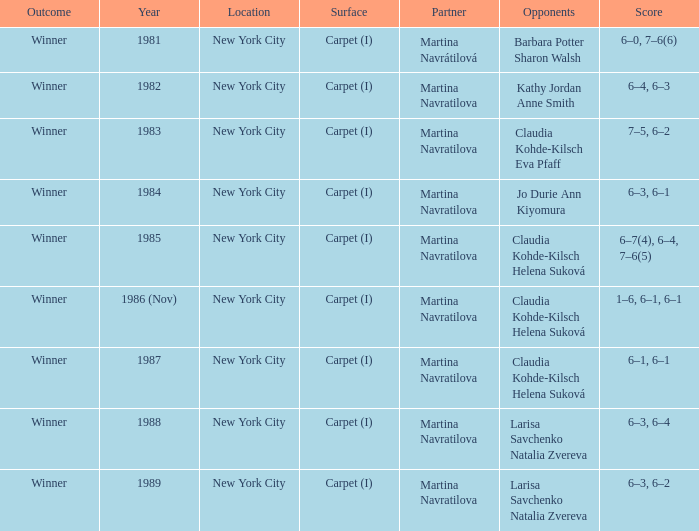Could you help me parse every detail presented in this table? {'header': ['Outcome', 'Year', 'Location', 'Surface', 'Partner', 'Opponents', 'Score'], 'rows': [['Winner', '1981', 'New York City', 'Carpet (I)', 'Martina Navrátilová', 'Barbara Potter Sharon Walsh', '6–0, 7–6(6)'], ['Winner', '1982', 'New York City', 'Carpet (I)', 'Martina Navratilova', 'Kathy Jordan Anne Smith', '6–4, 6–3'], ['Winner', '1983', 'New York City', 'Carpet (I)', 'Martina Navratilova', 'Claudia Kohde-Kilsch Eva Pfaff', '7–5, 6–2'], ['Winner', '1984', 'New York City', 'Carpet (I)', 'Martina Navratilova', 'Jo Durie Ann Kiyomura', '6–3, 6–1'], ['Winner', '1985', 'New York City', 'Carpet (I)', 'Martina Navratilova', 'Claudia Kohde-Kilsch Helena Suková', '6–7(4), 6–4, 7–6(5)'], ['Winner', '1986 (Nov)', 'New York City', 'Carpet (I)', 'Martina Navratilova', 'Claudia Kohde-Kilsch Helena Suková', '1–6, 6–1, 6–1'], ['Winner', '1987', 'New York City', 'Carpet (I)', 'Martina Navratilova', 'Claudia Kohde-Kilsch Helena Suková', '6–1, 6–1'], ['Winner', '1988', 'New York City', 'Carpet (I)', 'Martina Navratilova', 'Larisa Savchenko Natalia Zvereva', '6–3, 6–4'], ['Winner', '1989', 'New York City', 'Carpet (I)', 'Martina Navratilova', 'Larisa Savchenko Natalia Zvereva', '6–3, 6–2']]} At how many venues were claudia kohde-kilsch and eva pfaff hosted? 1.0. 